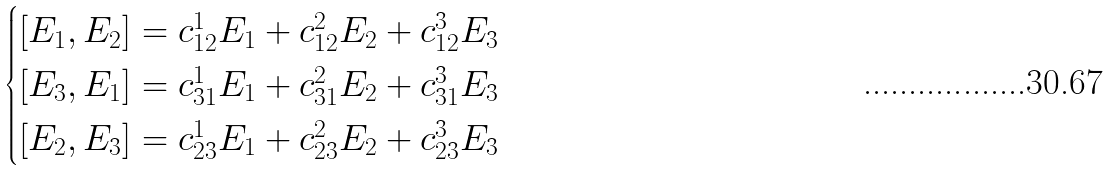Convert formula to latex. <formula><loc_0><loc_0><loc_500><loc_500>\begin{cases} [ E _ { 1 } , E _ { 2 } ] = c ^ { 1 } _ { 1 2 } E _ { 1 } + c ^ { 2 } _ { 1 2 } E _ { 2 } + c ^ { 3 } _ { 1 2 } E _ { 3 } \\ [ E _ { 3 } , E _ { 1 } ] = c ^ { 1 } _ { 3 1 } E _ { 1 } + c ^ { 2 } _ { 3 1 } E _ { 2 } + c ^ { 3 } _ { 3 1 } E _ { 3 } \\ [ E _ { 2 } , E _ { 3 } ] = c ^ { 1 } _ { 2 3 } E _ { 1 } + c ^ { 2 } _ { 2 3 } E _ { 2 } + c ^ { 3 } _ { 2 3 } E _ { 3 } \\ \end{cases}</formula> 